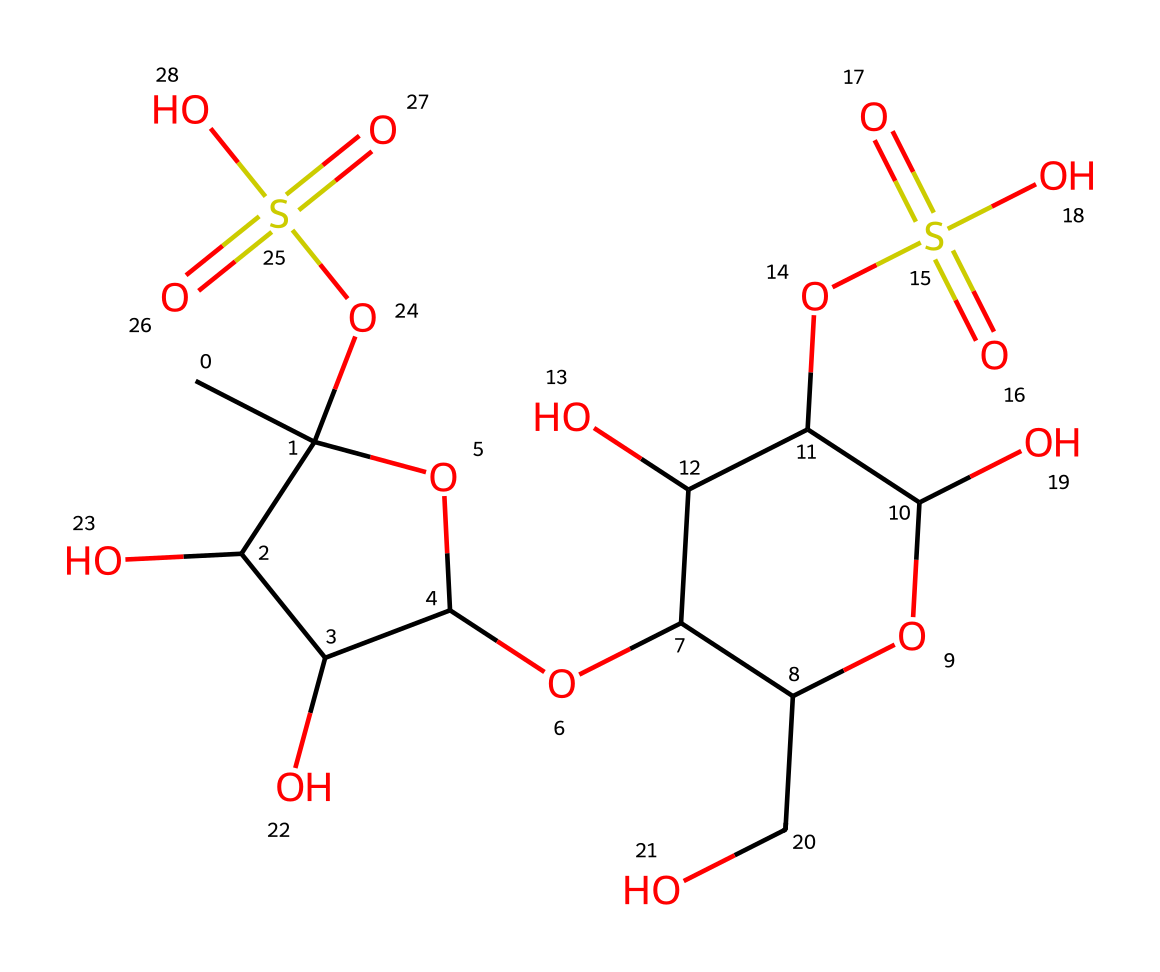What is the primary function of carrageenan in food products? Carrageenan acts primarily as a gelling agent and thickener, derived from seaweed, allowing food products to achieve desired textures.
Answer: gelling agent How many sulfate groups are present in carrageenan's structure? By analyzing the SMILES representation, we can identify two instances of "OS(=O)(=O)" which indicate two sulfate groups in the structure.
Answer: two What is the total number of carbon atoms in this chemical structure? Counting each "C" in the SMILES notation provides the total number of carbon atoms. The structure contains 14 carbon atoms in total.
Answer: fourteen Is carrageenan a natural or synthetic substance? The chemical structure shows it is derived from seaweed, which classifies it as a natural substance rather than a synthetic one.
Answer: natural What type of non-Newtonian behavior does carrageenan exhibit? Carrageenan exhibits shear-thinning behavior, meaning it becomes less viscous under increased stress, typical for substances used in food.
Answer: shear-thinning What role does the hydroxyl group play in carrageenan's properties? The hydroxyl groups increase hydrophilicity, allowing carrageenan to interact with water and contribute to its gelling properties.
Answer: hydrophilicity 